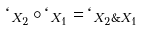<formula> <loc_0><loc_0><loc_500><loc_500>\ell _ { X _ { 2 } } \circ \ell _ { X _ { 1 } } = \ell _ { X _ { 2 } \& X _ { 1 } }</formula> 